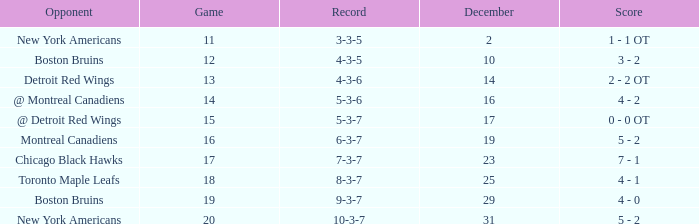Which December has a Record of 4-3-6? 14.0. 